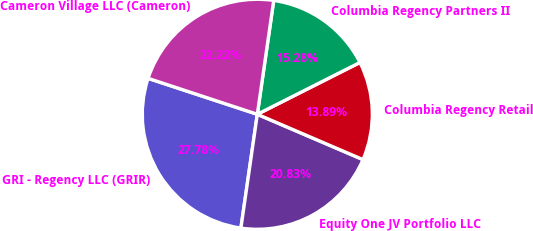Convert chart to OTSL. <chart><loc_0><loc_0><loc_500><loc_500><pie_chart><fcel>GRI - Regency LLC (GRIR)<fcel>Equity One JV Portfolio LLC<fcel>Columbia Regency Retail<fcel>Columbia Regency Partners II<fcel>Cameron Village LLC (Cameron)<nl><fcel>27.78%<fcel>20.83%<fcel>13.89%<fcel>15.28%<fcel>22.22%<nl></chart> 